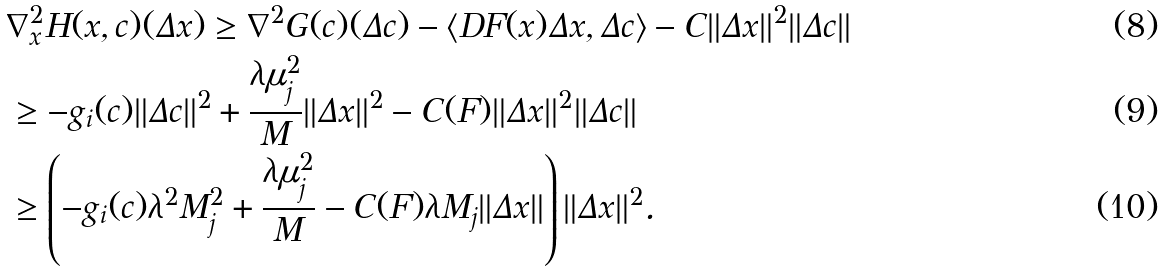<formula> <loc_0><loc_0><loc_500><loc_500>& \nabla _ { x } ^ { 2 } H ( x , c ) ( \Delta x ) \geq \nabla ^ { 2 } G ( c ) ( \Delta c ) - \langle D F ( x ) \Delta x , \Delta c \rangle - C \| \Delta x \| ^ { 2 } \| \Delta c \| \\ & \geq - g _ { i } ( c ) \| \Delta c \| ^ { 2 } + \frac { \lambda \mu _ { j } ^ { 2 } } { M } \| \Delta x \| ^ { 2 } - C ( F ) \| \Delta x \| ^ { 2 } \| \Delta c \| \\ & \geq \left ( - g _ { i } ( c ) \lambda ^ { 2 } M _ { j } ^ { 2 } + \frac { \lambda \mu _ { j } ^ { 2 } } { M } - C ( F ) \lambda M _ { j } \| \Delta x \| \right ) \| \Delta x \| ^ { 2 } .</formula> 